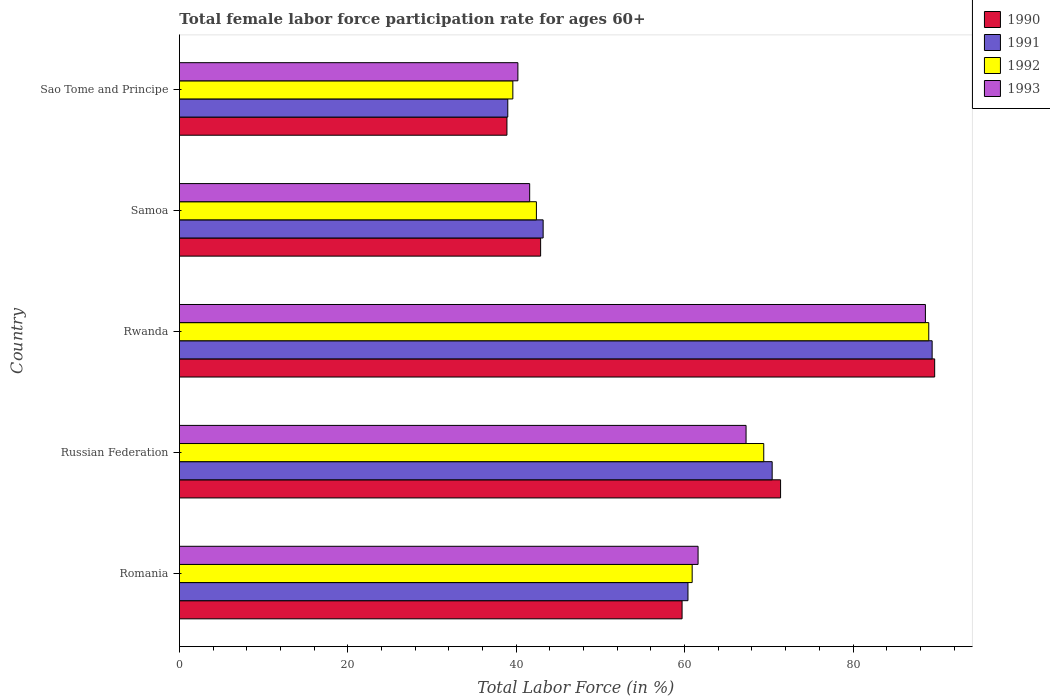How many different coloured bars are there?
Keep it short and to the point. 4. How many groups of bars are there?
Your answer should be compact. 5. Are the number of bars on each tick of the Y-axis equal?
Ensure brevity in your answer.  Yes. How many bars are there on the 4th tick from the bottom?
Offer a very short reply. 4. What is the label of the 3rd group of bars from the top?
Offer a very short reply. Rwanda. In how many cases, is the number of bars for a given country not equal to the number of legend labels?
Give a very brief answer. 0. What is the female labor force participation rate in 1993 in Samoa?
Your response must be concise. 41.6. Across all countries, what is the maximum female labor force participation rate in 1992?
Provide a succinct answer. 89. Across all countries, what is the minimum female labor force participation rate in 1990?
Offer a very short reply. 38.9. In which country was the female labor force participation rate in 1993 maximum?
Your response must be concise. Rwanda. In which country was the female labor force participation rate in 1992 minimum?
Your answer should be very brief. Sao Tome and Principe. What is the total female labor force participation rate in 1992 in the graph?
Offer a very short reply. 301.3. What is the difference between the female labor force participation rate in 1993 in Romania and that in Russian Federation?
Your answer should be very brief. -5.7. What is the difference between the female labor force participation rate in 1990 in Rwanda and the female labor force participation rate in 1992 in Romania?
Offer a terse response. 28.8. What is the average female labor force participation rate in 1990 per country?
Ensure brevity in your answer.  60.52. What is the difference between the female labor force participation rate in 1990 and female labor force participation rate in 1993 in Samoa?
Your answer should be very brief. 1.3. In how many countries, is the female labor force participation rate in 1992 greater than 68 %?
Provide a succinct answer. 2. What is the ratio of the female labor force participation rate in 1991 in Samoa to that in Sao Tome and Principe?
Ensure brevity in your answer.  1.11. Is the difference between the female labor force participation rate in 1990 in Russian Federation and Sao Tome and Principe greater than the difference between the female labor force participation rate in 1993 in Russian Federation and Sao Tome and Principe?
Your answer should be compact. Yes. What is the difference between the highest and the second highest female labor force participation rate in 1991?
Provide a short and direct response. 19. What is the difference between the highest and the lowest female labor force participation rate in 1990?
Your answer should be very brief. 50.8. In how many countries, is the female labor force participation rate in 1992 greater than the average female labor force participation rate in 1992 taken over all countries?
Provide a short and direct response. 3. Is it the case that in every country, the sum of the female labor force participation rate in 1991 and female labor force participation rate in 1993 is greater than the female labor force participation rate in 1992?
Offer a very short reply. Yes. Are all the bars in the graph horizontal?
Offer a very short reply. Yes. How many countries are there in the graph?
Provide a short and direct response. 5. Are the values on the major ticks of X-axis written in scientific E-notation?
Provide a succinct answer. No. Does the graph contain any zero values?
Give a very brief answer. No. Does the graph contain grids?
Offer a terse response. No. Where does the legend appear in the graph?
Your response must be concise. Top right. What is the title of the graph?
Your answer should be compact. Total female labor force participation rate for ages 60+. What is the Total Labor Force (in %) in 1990 in Romania?
Ensure brevity in your answer.  59.7. What is the Total Labor Force (in %) in 1991 in Romania?
Give a very brief answer. 60.4. What is the Total Labor Force (in %) of 1992 in Romania?
Make the answer very short. 60.9. What is the Total Labor Force (in %) in 1993 in Romania?
Your answer should be very brief. 61.6. What is the Total Labor Force (in %) in 1990 in Russian Federation?
Ensure brevity in your answer.  71.4. What is the Total Labor Force (in %) in 1991 in Russian Federation?
Provide a short and direct response. 70.4. What is the Total Labor Force (in %) of 1992 in Russian Federation?
Make the answer very short. 69.4. What is the Total Labor Force (in %) of 1993 in Russian Federation?
Offer a very short reply. 67.3. What is the Total Labor Force (in %) in 1990 in Rwanda?
Ensure brevity in your answer.  89.7. What is the Total Labor Force (in %) in 1991 in Rwanda?
Offer a terse response. 89.4. What is the Total Labor Force (in %) in 1992 in Rwanda?
Your answer should be very brief. 89. What is the Total Labor Force (in %) in 1993 in Rwanda?
Ensure brevity in your answer.  88.6. What is the Total Labor Force (in %) in 1990 in Samoa?
Make the answer very short. 42.9. What is the Total Labor Force (in %) in 1991 in Samoa?
Your answer should be compact. 43.2. What is the Total Labor Force (in %) of 1992 in Samoa?
Provide a short and direct response. 42.4. What is the Total Labor Force (in %) of 1993 in Samoa?
Ensure brevity in your answer.  41.6. What is the Total Labor Force (in %) in 1990 in Sao Tome and Principe?
Your response must be concise. 38.9. What is the Total Labor Force (in %) in 1991 in Sao Tome and Principe?
Your answer should be compact. 39. What is the Total Labor Force (in %) in 1992 in Sao Tome and Principe?
Offer a very short reply. 39.6. What is the Total Labor Force (in %) in 1993 in Sao Tome and Principe?
Offer a very short reply. 40.2. Across all countries, what is the maximum Total Labor Force (in %) of 1990?
Your answer should be compact. 89.7. Across all countries, what is the maximum Total Labor Force (in %) in 1991?
Offer a terse response. 89.4. Across all countries, what is the maximum Total Labor Force (in %) in 1992?
Your answer should be compact. 89. Across all countries, what is the maximum Total Labor Force (in %) in 1993?
Offer a very short reply. 88.6. Across all countries, what is the minimum Total Labor Force (in %) in 1990?
Keep it short and to the point. 38.9. Across all countries, what is the minimum Total Labor Force (in %) in 1991?
Offer a very short reply. 39. Across all countries, what is the minimum Total Labor Force (in %) of 1992?
Your answer should be very brief. 39.6. Across all countries, what is the minimum Total Labor Force (in %) in 1993?
Offer a terse response. 40.2. What is the total Total Labor Force (in %) in 1990 in the graph?
Provide a succinct answer. 302.6. What is the total Total Labor Force (in %) in 1991 in the graph?
Ensure brevity in your answer.  302.4. What is the total Total Labor Force (in %) of 1992 in the graph?
Keep it short and to the point. 301.3. What is the total Total Labor Force (in %) in 1993 in the graph?
Ensure brevity in your answer.  299.3. What is the difference between the Total Labor Force (in %) in 1990 in Romania and that in Russian Federation?
Provide a succinct answer. -11.7. What is the difference between the Total Labor Force (in %) in 1991 in Romania and that in Russian Federation?
Offer a terse response. -10. What is the difference between the Total Labor Force (in %) of 1992 in Romania and that in Rwanda?
Your answer should be compact. -28.1. What is the difference between the Total Labor Force (in %) in 1993 in Romania and that in Rwanda?
Offer a very short reply. -27. What is the difference between the Total Labor Force (in %) of 1992 in Romania and that in Samoa?
Provide a short and direct response. 18.5. What is the difference between the Total Labor Force (in %) of 1993 in Romania and that in Samoa?
Offer a very short reply. 20. What is the difference between the Total Labor Force (in %) in 1990 in Romania and that in Sao Tome and Principe?
Provide a short and direct response. 20.8. What is the difference between the Total Labor Force (in %) in 1991 in Romania and that in Sao Tome and Principe?
Keep it short and to the point. 21.4. What is the difference between the Total Labor Force (in %) of 1992 in Romania and that in Sao Tome and Principe?
Ensure brevity in your answer.  21.3. What is the difference between the Total Labor Force (in %) of 1993 in Romania and that in Sao Tome and Principe?
Offer a terse response. 21.4. What is the difference between the Total Labor Force (in %) in 1990 in Russian Federation and that in Rwanda?
Keep it short and to the point. -18.3. What is the difference between the Total Labor Force (in %) in 1991 in Russian Federation and that in Rwanda?
Provide a succinct answer. -19. What is the difference between the Total Labor Force (in %) of 1992 in Russian Federation and that in Rwanda?
Offer a terse response. -19.6. What is the difference between the Total Labor Force (in %) in 1993 in Russian Federation and that in Rwanda?
Offer a very short reply. -21.3. What is the difference between the Total Labor Force (in %) in 1990 in Russian Federation and that in Samoa?
Ensure brevity in your answer.  28.5. What is the difference between the Total Labor Force (in %) in 1991 in Russian Federation and that in Samoa?
Give a very brief answer. 27.2. What is the difference between the Total Labor Force (in %) of 1992 in Russian Federation and that in Samoa?
Make the answer very short. 27. What is the difference between the Total Labor Force (in %) in 1993 in Russian Federation and that in Samoa?
Offer a terse response. 25.7. What is the difference between the Total Labor Force (in %) in 1990 in Russian Federation and that in Sao Tome and Principe?
Make the answer very short. 32.5. What is the difference between the Total Labor Force (in %) in 1991 in Russian Federation and that in Sao Tome and Principe?
Make the answer very short. 31.4. What is the difference between the Total Labor Force (in %) of 1992 in Russian Federation and that in Sao Tome and Principe?
Ensure brevity in your answer.  29.8. What is the difference between the Total Labor Force (in %) in 1993 in Russian Federation and that in Sao Tome and Principe?
Make the answer very short. 27.1. What is the difference between the Total Labor Force (in %) in 1990 in Rwanda and that in Samoa?
Your answer should be very brief. 46.8. What is the difference between the Total Labor Force (in %) in 1991 in Rwanda and that in Samoa?
Provide a short and direct response. 46.2. What is the difference between the Total Labor Force (in %) of 1992 in Rwanda and that in Samoa?
Provide a short and direct response. 46.6. What is the difference between the Total Labor Force (in %) in 1990 in Rwanda and that in Sao Tome and Principe?
Your answer should be very brief. 50.8. What is the difference between the Total Labor Force (in %) of 1991 in Rwanda and that in Sao Tome and Principe?
Your response must be concise. 50.4. What is the difference between the Total Labor Force (in %) of 1992 in Rwanda and that in Sao Tome and Principe?
Keep it short and to the point. 49.4. What is the difference between the Total Labor Force (in %) in 1993 in Rwanda and that in Sao Tome and Principe?
Offer a terse response. 48.4. What is the difference between the Total Labor Force (in %) of 1990 in Samoa and that in Sao Tome and Principe?
Provide a succinct answer. 4. What is the difference between the Total Labor Force (in %) of 1991 in Samoa and that in Sao Tome and Principe?
Offer a very short reply. 4.2. What is the difference between the Total Labor Force (in %) of 1990 in Romania and the Total Labor Force (in %) of 1993 in Russian Federation?
Offer a terse response. -7.6. What is the difference between the Total Labor Force (in %) in 1991 in Romania and the Total Labor Force (in %) in 1993 in Russian Federation?
Your answer should be compact. -6.9. What is the difference between the Total Labor Force (in %) of 1990 in Romania and the Total Labor Force (in %) of 1991 in Rwanda?
Your response must be concise. -29.7. What is the difference between the Total Labor Force (in %) of 1990 in Romania and the Total Labor Force (in %) of 1992 in Rwanda?
Your answer should be compact. -29.3. What is the difference between the Total Labor Force (in %) of 1990 in Romania and the Total Labor Force (in %) of 1993 in Rwanda?
Your answer should be very brief. -28.9. What is the difference between the Total Labor Force (in %) in 1991 in Romania and the Total Labor Force (in %) in 1992 in Rwanda?
Your response must be concise. -28.6. What is the difference between the Total Labor Force (in %) of 1991 in Romania and the Total Labor Force (in %) of 1993 in Rwanda?
Offer a terse response. -28.2. What is the difference between the Total Labor Force (in %) of 1992 in Romania and the Total Labor Force (in %) of 1993 in Rwanda?
Give a very brief answer. -27.7. What is the difference between the Total Labor Force (in %) of 1990 in Romania and the Total Labor Force (in %) of 1991 in Samoa?
Keep it short and to the point. 16.5. What is the difference between the Total Labor Force (in %) in 1990 in Romania and the Total Labor Force (in %) in 1993 in Samoa?
Your response must be concise. 18.1. What is the difference between the Total Labor Force (in %) of 1991 in Romania and the Total Labor Force (in %) of 1992 in Samoa?
Keep it short and to the point. 18. What is the difference between the Total Labor Force (in %) in 1991 in Romania and the Total Labor Force (in %) in 1993 in Samoa?
Your answer should be very brief. 18.8. What is the difference between the Total Labor Force (in %) of 1992 in Romania and the Total Labor Force (in %) of 1993 in Samoa?
Offer a very short reply. 19.3. What is the difference between the Total Labor Force (in %) of 1990 in Romania and the Total Labor Force (in %) of 1991 in Sao Tome and Principe?
Your response must be concise. 20.7. What is the difference between the Total Labor Force (in %) of 1990 in Romania and the Total Labor Force (in %) of 1992 in Sao Tome and Principe?
Your response must be concise. 20.1. What is the difference between the Total Labor Force (in %) in 1990 in Romania and the Total Labor Force (in %) in 1993 in Sao Tome and Principe?
Your answer should be compact. 19.5. What is the difference between the Total Labor Force (in %) in 1991 in Romania and the Total Labor Force (in %) in 1992 in Sao Tome and Principe?
Keep it short and to the point. 20.8. What is the difference between the Total Labor Force (in %) in 1991 in Romania and the Total Labor Force (in %) in 1993 in Sao Tome and Principe?
Your answer should be compact. 20.2. What is the difference between the Total Labor Force (in %) in 1992 in Romania and the Total Labor Force (in %) in 1993 in Sao Tome and Principe?
Your answer should be very brief. 20.7. What is the difference between the Total Labor Force (in %) in 1990 in Russian Federation and the Total Labor Force (in %) in 1992 in Rwanda?
Your answer should be compact. -17.6. What is the difference between the Total Labor Force (in %) of 1990 in Russian Federation and the Total Labor Force (in %) of 1993 in Rwanda?
Keep it short and to the point. -17.2. What is the difference between the Total Labor Force (in %) of 1991 in Russian Federation and the Total Labor Force (in %) of 1992 in Rwanda?
Offer a terse response. -18.6. What is the difference between the Total Labor Force (in %) in 1991 in Russian Federation and the Total Labor Force (in %) in 1993 in Rwanda?
Offer a very short reply. -18.2. What is the difference between the Total Labor Force (in %) of 1992 in Russian Federation and the Total Labor Force (in %) of 1993 in Rwanda?
Give a very brief answer. -19.2. What is the difference between the Total Labor Force (in %) of 1990 in Russian Federation and the Total Labor Force (in %) of 1991 in Samoa?
Make the answer very short. 28.2. What is the difference between the Total Labor Force (in %) in 1990 in Russian Federation and the Total Labor Force (in %) in 1993 in Samoa?
Provide a succinct answer. 29.8. What is the difference between the Total Labor Force (in %) of 1991 in Russian Federation and the Total Labor Force (in %) of 1993 in Samoa?
Give a very brief answer. 28.8. What is the difference between the Total Labor Force (in %) of 1992 in Russian Federation and the Total Labor Force (in %) of 1993 in Samoa?
Provide a succinct answer. 27.8. What is the difference between the Total Labor Force (in %) of 1990 in Russian Federation and the Total Labor Force (in %) of 1991 in Sao Tome and Principe?
Offer a terse response. 32.4. What is the difference between the Total Labor Force (in %) in 1990 in Russian Federation and the Total Labor Force (in %) in 1992 in Sao Tome and Principe?
Your answer should be very brief. 31.8. What is the difference between the Total Labor Force (in %) in 1990 in Russian Federation and the Total Labor Force (in %) in 1993 in Sao Tome and Principe?
Provide a succinct answer. 31.2. What is the difference between the Total Labor Force (in %) of 1991 in Russian Federation and the Total Labor Force (in %) of 1992 in Sao Tome and Principe?
Keep it short and to the point. 30.8. What is the difference between the Total Labor Force (in %) of 1991 in Russian Federation and the Total Labor Force (in %) of 1993 in Sao Tome and Principe?
Your response must be concise. 30.2. What is the difference between the Total Labor Force (in %) in 1992 in Russian Federation and the Total Labor Force (in %) in 1993 in Sao Tome and Principe?
Provide a short and direct response. 29.2. What is the difference between the Total Labor Force (in %) of 1990 in Rwanda and the Total Labor Force (in %) of 1991 in Samoa?
Offer a very short reply. 46.5. What is the difference between the Total Labor Force (in %) of 1990 in Rwanda and the Total Labor Force (in %) of 1992 in Samoa?
Keep it short and to the point. 47.3. What is the difference between the Total Labor Force (in %) in 1990 in Rwanda and the Total Labor Force (in %) in 1993 in Samoa?
Offer a very short reply. 48.1. What is the difference between the Total Labor Force (in %) in 1991 in Rwanda and the Total Labor Force (in %) in 1993 in Samoa?
Keep it short and to the point. 47.8. What is the difference between the Total Labor Force (in %) of 1992 in Rwanda and the Total Labor Force (in %) of 1993 in Samoa?
Your answer should be compact. 47.4. What is the difference between the Total Labor Force (in %) of 1990 in Rwanda and the Total Labor Force (in %) of 1991 in Sao Tome and Principe?
Offer a very short reply. 50.7. What is the difference between the Total Labor Force (in %) of 1990 in Rwanda and the Total Labor Force (in %) of 1992 in Sao Tome and Principe?
Offer a very short reply. 50.1. What is the difference between the Total Labor Force (in %) of 1990 in Rwanda and the Total Labor Force (in %) of 1993 in Sao Tome and Principe?
Ensure brevity in your answer.  49.5. What is the difference between the Total Labor Force (in %) of 1991 in Rwanda and the Total Labor Force (in %) of 1992 in Sao Tome and Principe?
Ensure brevity in your answer.  49.8. What is the difference between the Total Labor Force (in %) of 1991 in Rwanda and the Total Labor Force (in %) of 1993 in Sao Tome and Principe?
Offer a terse response. 49.2. What is the difference between the Total Labor Force (in %) of 1992 in Rwanda and the Total Labor Force (in %) of 1993 in Sao Tome and Principe?
Ensure brevity in your answer.  48.8. What is the difference between the Total Labor Force (in %) of 1990 in Samoa and the Total Labor Force (in %) of 1991 in Sao Tome and Principe?
Offer a terse response. 3.9. What is the difference between the Total Labor Force (in %) in 1990 in Samoa and the Total Labor Force (in %) in 1992 in Sao Tome and Principe?
Your answer should be very brief. 3.3. What is the difference between the Total Labor Force (in %) in 1991 in Samoa and the Total Labor Force (in %) in 1993 in Sao Tome and Principe?
Offer a terse response. 3. What is the difference between the Total Labor Force (in %) of 1992 in Samoa and the Total Labor Force (in %) of 1993 in Sao Tome and Principe?
Keep it short and to the point. 2.2. What is the average Total Labor Force (in %) of 1990 per country?
Provide a succinct answer. 60.52. What is the average Total Labor Force (in %) in 1991 per country?
Offer a very short reply. 60.48. What is the average Total Labor Force (in %) in 1992 per country?
Offer a terse response. 60.26. What is the average Total Labor Force (in %) in 1993 per country?
Your answer should be compact. 59.86. What is the difference between the Total Labor Force (in %) in 1990 and Total Labor Force (in %) in 1991 in Romania?
Ensure brevity in your answer.  -0.7. What is the difference between the Total Labor Force (in %) in 1990 and Total Labor Force (in %) in 1992 in Romania?
Provide a succinct answer. -1.2. What is the difference between the Total Labor Force (in %) in 1991 and Total Labor Force (in %) in 1992 in Romania?
Make the answer very short. -0.5. What is the difference between the Total Labor Force (in %) in 1991 and Total Labor Force (in %) in 1993 in Romania?
Make the answer very short. -1.2. What is the difference between the Total Labor Force (in %) in 1992 and Total Labor Force (in %) in 1993 in Romania?
Ensure brevity in your answer.  -0.7. What is the difference between the Total Labor Force (in %) in 1991 and Total Labor Force (in %) in 1993 in Russian Federation?
Provide a succinct answer. 3.1. What is the difference between the Total Labor Force (in %) in 1992 and Total Labor Force (in %) in 1993 in Russian Federation?
Make the answer very short. 2.1. What is the difference between the Total Labor Force (in %) in 1990 and Total Labor Force (in %) in 1992 in Rwanda?
Give a very brief answer. 0.7. What is the difference between the Total Labor Force (in %) of 1991 and Total Labor Force (in %) of 1993 in Rwanda?
Provide a short and direct response. 0.8. What is the difference between the Total Labor Force (in %) of 1990 and Total Labor Force (in %) of 1993 in Samoa?
Provide a short and direct response. 1.3. What is the difference between the Total Labor Force (in %) in 1991 and Total Labor Force (in %) in 1992 in Samoa?
Give a very brief answer. 0.8. What is the difference between the Total Labor Force (in %) in 1991 and Total Labor Force (in %) in 1993 in Samoa?
Provide a short and direct response. 1.6. What is the difference between the Total Labor Force (in %) of 1992 and Total Labor Force (in %) of 1993 in Samoa?
Provide a succinct answer. 0.8. What is the difference between the Total Labor Force (in %) in 1990 and Total Labor Force (in %) in 1992 in Sao Tome and Principe?
Your answer should be compact. -0.7. What is the difference between the Total Labor Force (in %) in 1991 and Total Labor Force (in %) in 1992 in Sao Tome and Principe?
Offer a very short reply. -0.6. What is the difference between the Total Labor Force (in %) in 1991 and Total Labor Force (in %) in 1993 in Sao Tome and Principe?
Make the answer very short. -1.2. What is the ratio of the Total Labor Force (in %) in 1990 in Romania to that in Russian Federation?
Your answer should be compact. 0.84. What is the ratio of the Total Labor Force (in %) in 1991 in Romania to that in Russian Federation?
Your response must be concise. 0.86. What is the ratio of the Total Labor Force (in %) in 1992 in Romania to that in Russian Federation?
Ensure brevity in your answer.  0.88. What is the ratio of the Total Labor Force (in %) of 1993 in Romania to that in Russian Federation?
Offer a very short reply. 0.92. What is the ratio of the Total Labor Force (in %) in 1990 in Romania to that in Rwanda?
Provide a short and direct response. 0.67. What is the ratio of the Total Labor Force (in %) in 1991 in Romania to that in Rwanda?
Offer a very short reply. 0.68. What is the ratio of the Total Labor Force (in %) of 1992 in Romania to that in Rwanda?
Keep it short and to the point. 0.68. What is the ratio of the Total Labor Force (in %) in 1993 in Romania to that in Rwanda?
Provide a short and direct response. 0.7. What is the ratio of the Total Labor Force (in %) of 1990 in Romania to that in Samoa?
Ensure brevity in your answer.  1.39. What is the ratio of the Total Labor Force (in %) of 1991 in Romania to that in Samoa?
Give a very brief answer. 1.4. What is the ratio of the Total Labor Force (in %) in 1992 in Romania to that in Samoa?
Your answer should be compact. 1.44. What is the ratio of the Total Labor Force (in %) of 1993 in Romania to that in Samoa?
Give a very brief answer. 1.48. What is the ratio of the Total Labor Force (in %) in 1990 in Romania to that in Sao Tome and Principe?
Your answer should be compact. 1.53. What is the ratio of the Total Labor Force (in %) of 1991 in Romania to that in Sao Tome and Principe?
Provide a short and direct response. 1.55. What is the ratio of the Total Labor Force (in %) in 1992 in Romania to that in Sao Tome and Principe?
Keep it short and to the point. 1.54. What is the ratio of the Total Labor Force (in %) in 1993 in Romania to that in Sao Tome and Principe?
Give a very brief answer. 1.53. What is the ratio of the Total Labor Force (in %) in 1990 in Russian Federation to that in Rwanda?
Keep it short and to the point. 0.8. What is the ratio of the Total Labor Force (in %) of 1991 in Russian Federation to that in Rwanda?
Ensure brevity in your answer.  0.79. What is the ratio of the Total Labor Force (in %) of 1992 in Russian Federation to that in Rwanda?
Offer a very short reply. 0.78. What is the ratio of the Total Labor Force (in %) in 1993 in Russian Federation to that in Rwanda?
Offer a terse response. 0.76. What is the ratio of the Total Labor Force (in %) in 1990 in Russian Federation to that in Samoa?
Give a very brief answer. 1.66. What is the ratio of the Total Labor Force (in %) in 1991 in Russian Federation to that in Samoa?
Make the answer very short. 1.63. What is the ratio of the Total Labor Force (in %) of 1992 in Russian Federation to that in Samoa?
Provide a succinct answer. 1.64. What is the ratio of the Total Labor Force (in %) of 1993 in Russian Federation to that in Samoa?
Make the answer very short. 1.62. What is the ratio of the Total Labor Force (in %) in 1990 in Russian Federation to that in Sao Tome and Principe?
Offer a terse response. 1.84. What is the ratio of the Total Labor Force (in %) in 1991 in Russian Federation to that in Sao Tome and Principe?
Make the answer very short. 1.81. What is the ratio of the Total Labor Force (in %) in 1992 in Russian Federation to that in Sao Tome and Principe?
Your answer should be compact. 1.75. What is the ratio of the Total Labor Force (in %) of 1993 in Russian Federation to that in Sao Tome and Principe?
Keep it short and to the point. 1.67. What is the ratio of the Total Labor Force (in %) in 1990 in Rwanda to that in Samoa?
Make the answer very short. 2.09. What is the ratio of the Total Labor Force (in %) of 1991 in Rwanda to that in Samoa?
Offer a terse response. 2.07. What is the ratio of the Total Labor Force (in %) of 1992 in Rwanda to that in Samoa?
Your answer should be very brief. 2.1. What is the ratio of the Total Labor Force (in %) of 1993 in Rwanda to that in Samoa?
Offer a terse response. 2.13. What is the ratio of the Total Labor Force (in %) of 1990 in Rwanda to that in Sao Tome and Principe?
Ensure brevity in your answer.  2.31. What is the ratio of the Total Labor Force (in %) in 1991 in Rwanda to that in Sao Tome and Principe?
Offer a very short reply. 2.29. What is the ratio of the Total Labor Force (in %) of 1992 in Rwanda to that in Sao Tome and Principe?
Your answer should be compact. 2.25. What is the ratio of the Total Labor Force (in %) of 1993 in Rwanda to that in Sao Tome and Principe?
Keep it short and to the point. 2.2. What is the ratio of the Total Labor Force (in %) of 1990 in Samoa to that in Sao Tome and Principe?
Your answer should be very brief. 1.1. What is the ratio of the Total Labor Force (in %) in 1991 in Samoa to that in Sao Tome and Principe?
Offer a very short reply. 1.11. What is the ratio of the Total Labor Force (in %) of 1992 in Samoa to that in Sao Tome and Principe?
Keep it short and to the point. 1.07. What is the ratio of the Total Labor Force (in %) in 1993 in Samoa to that in Sao Tome and Principe?
Your response must be concise. 1.03. What is the difference between the highest and the second highest Total Labor Force (in %) in 1992?
Offer a terse response. 19.6. What is the difference between the highest and the second highest Total Labor Force (in %) of 1993?
Offer a terse response. 21.3. What is the difference between the highest and the lowest Total Labor Force (in %) of 1990?
Your answer should be compact. 50.8. What is the difference between the highest and the lowest Total Labor Force (in %) in 1991?
Offer a very short reply. 50.4. What is the difference between the highest and the lowest Total Labor Force (in %) in 1992?
Give a very brief answer. 49.4. What is the difference between the highest and the lowest Total Labor Force (in %) in 1993?
Keep it short and to the point. 48.4. 